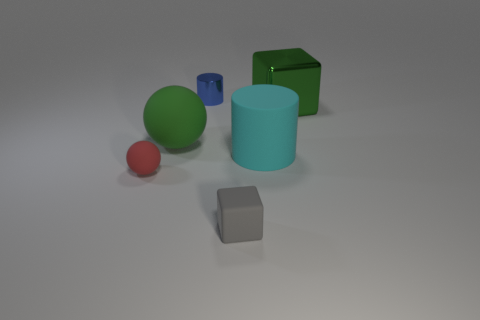Are there any blue objects made of the same material as the tiny ball?
Your answer should be compact. No. The matte object that is both on the right side of the blue cylinder and to the left of the large rubber cylinder has what shape?
Provide a succinct answer. Cube. What number of other things are the same shape as the large green shiny thing?
Ensure brevity in your answer.  1. The green rubber ball is what size?
Make the answer very short. Large. What number of objects are green rubber things or big cyan matte cubes?
Offer a very short reply. 1. There is a red rubber sphere that is in front of the small blue shiny cylinder; what size is it?
Offer a very short reply. Small. Is there anything else that is the same size as the rubber cube?
Your response must be concise. Yes. What is the color of the rubber object that is in front of the cyan matte object and on the left side of the tiny blue cylinder?
Your answer should be very brief. Red. Are the tiny thing that is in front of the red matte thing and the cyan cylinder made of the same material?
Ensure brevity in your answer.  Yes. Do the small ball and the tiny thing in front of the tiny red object have the same color?
Your response must be concise. No. 